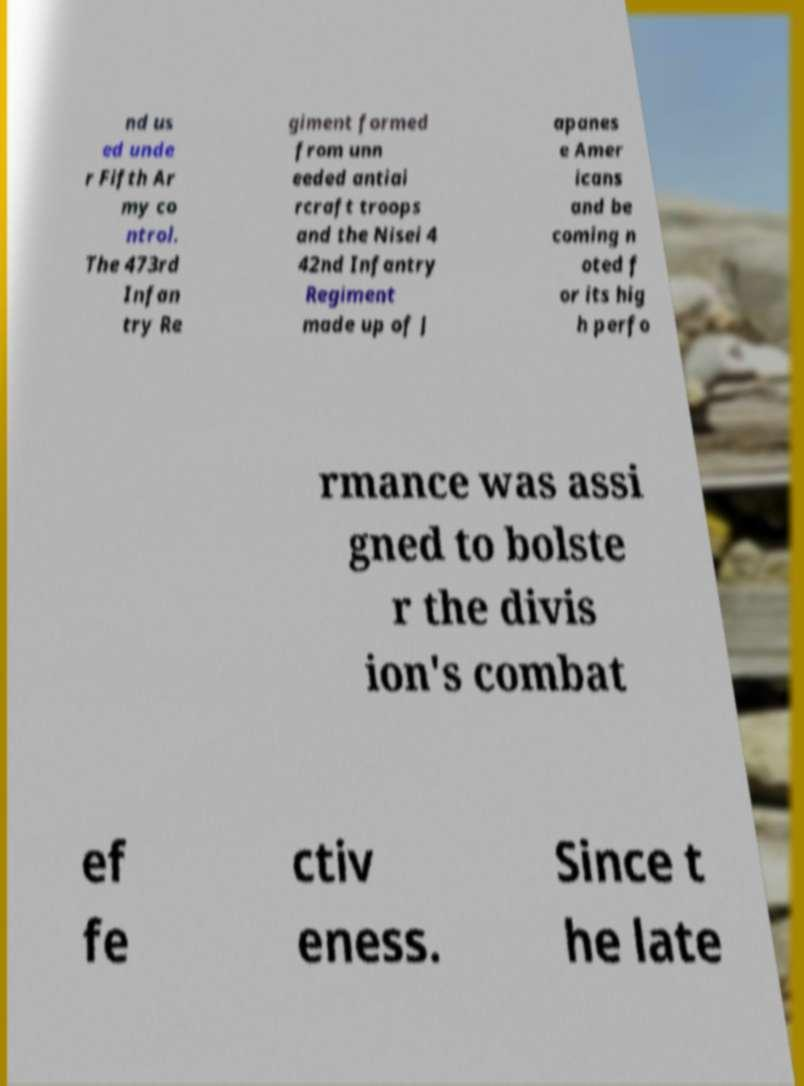Can you read and provide the text displayed in the image?This photo seems to have some interesting text. Can you extract and type it out for me? nd us ed unde r Fifth Ar my co ntrol. The 473rd Infan try Re giment formed from unn eeded antiai rcraft troops and the Nisei 4 42nd Infantry Regiment made up of J apanes e Amer icans and be coming n oted f or its hig h perfo rmance was assi gned to bolste r the divis ion's combat ef fe ctiv eness. Since t he late 